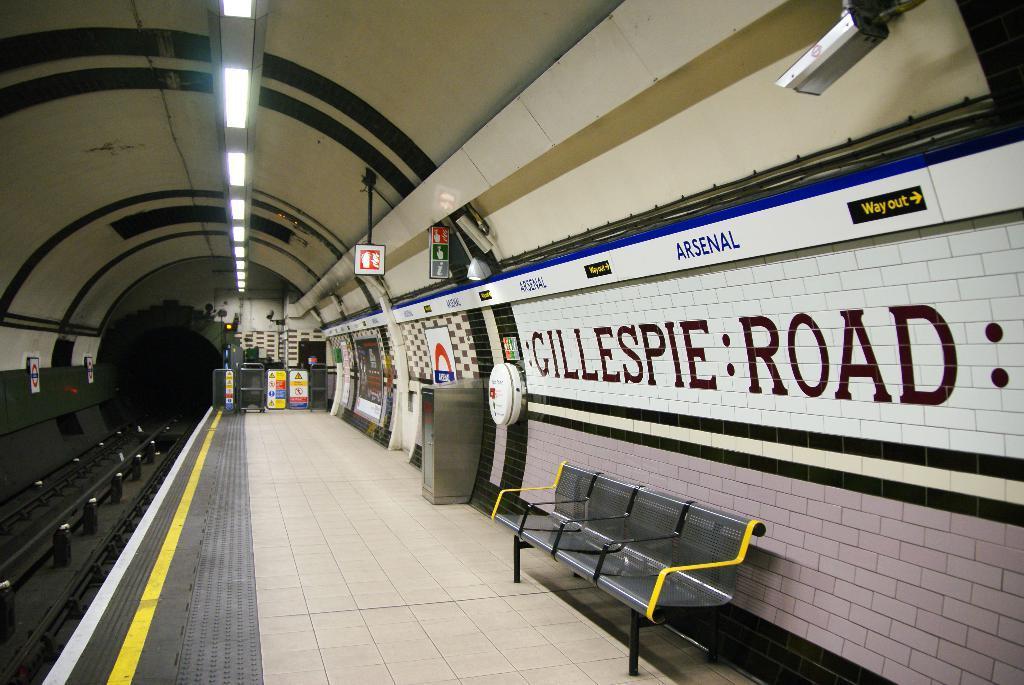Could you give a brief overview of what you see in this image? This image looks like a tunnel. This looks like a platform. There is a bench at the bottom. There are lights at the top. 